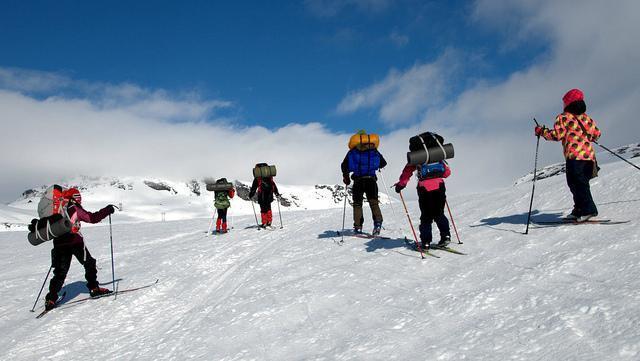How many people are there?
Give a very brief answer. 6. How many skiers are going uphill?
Give a very brief answer. 6. How many people are in the photo?
Give a very brief answer. 4. How many umbrellas have more than 4 colors?
Give a very brief answer. 0. 